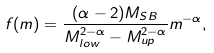Convert formula to latex. <formula><loc_0><loc_0><loc_500><loc_500>f ( m ) = \frac { ( \alpha - 2 ) M _ { S B } } { M _ { l o w } ^ { 2 - \alpha } - M _ { u p } ^ { 2 - \alpha } } m ^ { - \alpha } ,</formula> 